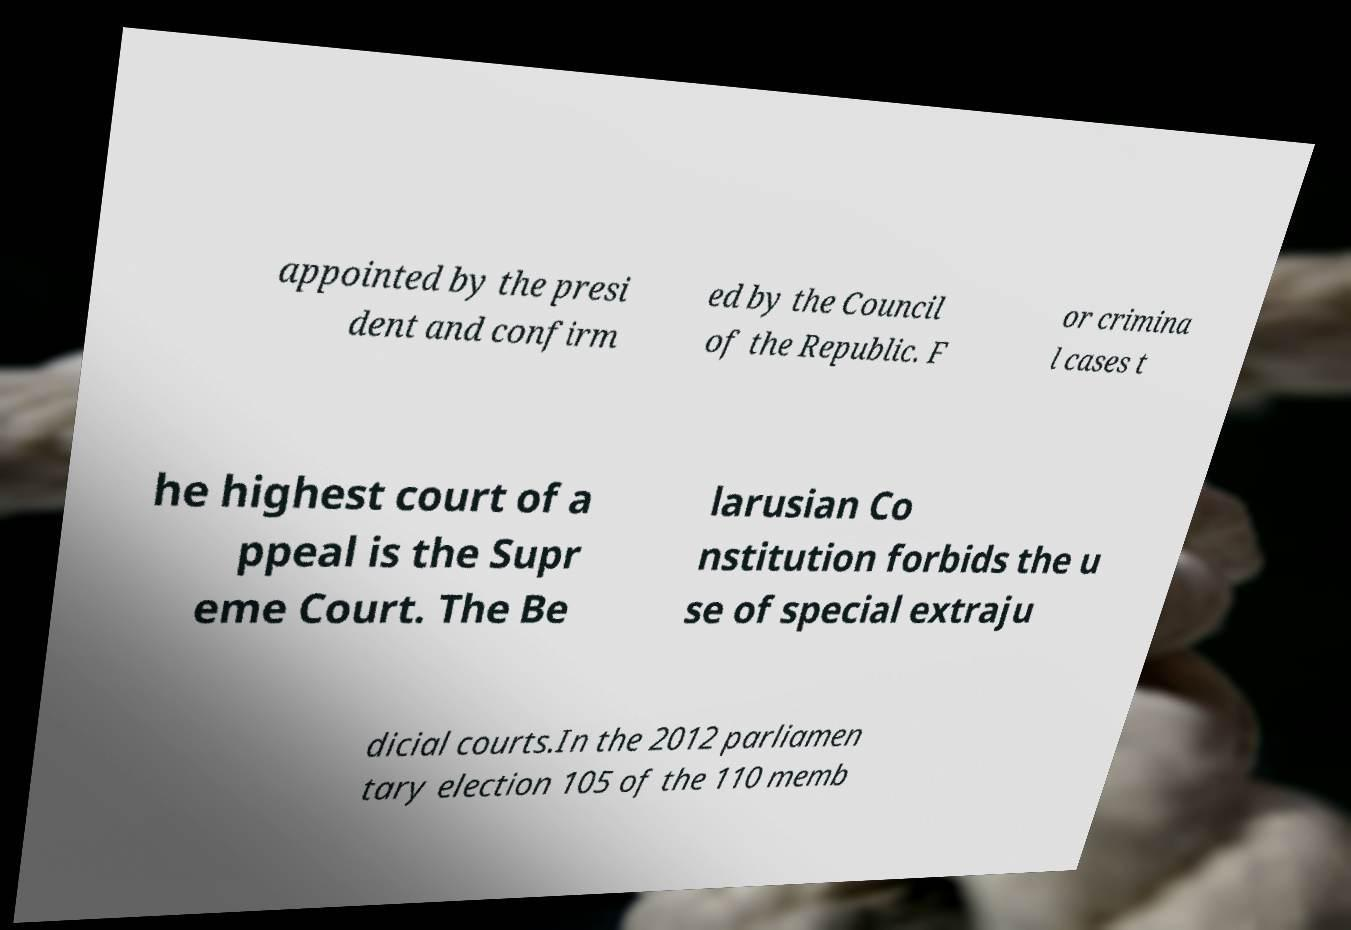Could you assist in decoding the text presented in this image and type it out clearly? appointed by the presi dent and confirm ed by the Council of the Republic. F or crimina l cases t he highest court of a ppeal is the Supr eme Court. The Be larusian Co nstitution forbids the u se of special extraju dicial courts.In the 2012 parliamen tary election 105 of the 110 memb 